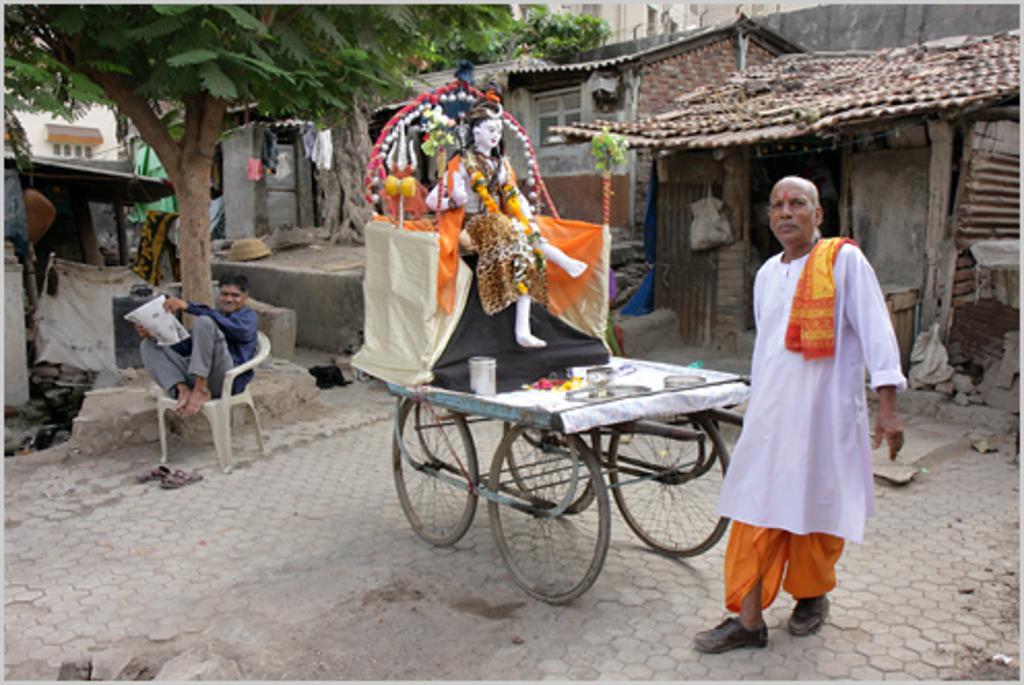In one or two sentences, can you explain what this image depicts? Person standing near the vehicle and a person sitting. man sitting on the chair,in the back we have trees and houses. 